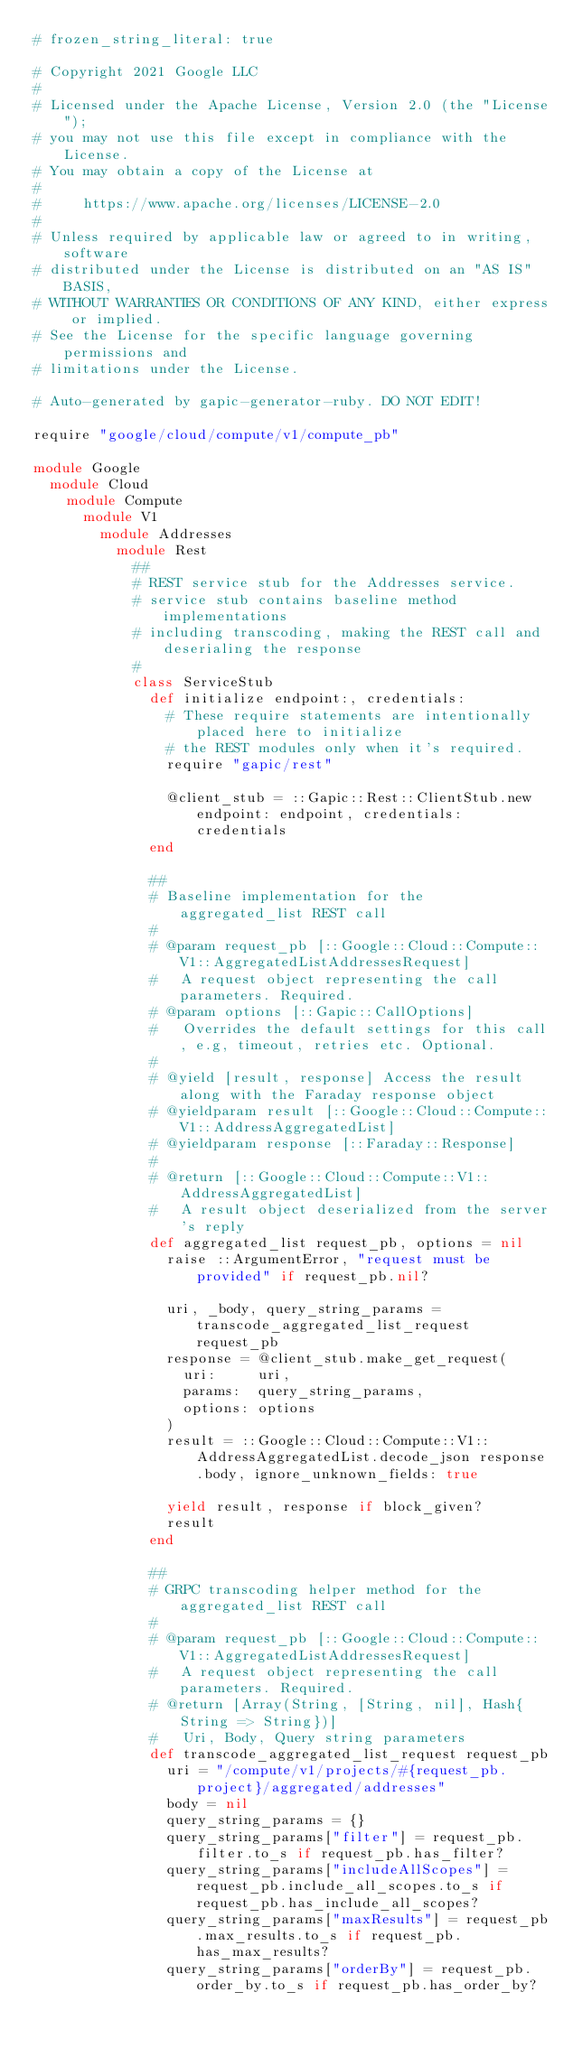Convert code to text. <code><loc_0><loc_0><loc_500><loc_500><_Ruby_># frozen_string_literal: true

# Copyright 2021 Google LLC
#
# Licensed under the Apache License, Version 2.0 (the "License");
# you may not use this file except in compliance with the License.
# You may obtain a copy of the License at
#
#     https://www.apache.org/licenses/LICENSE-2.0
#
# Unless required by applicable law or agreed to in writing, software
# distributed under the License is distributed on an "AS IS" BASIS,
# WITHOUT WARRANTIES OR CONDITIONS OF ANY KIND, either express or implied.
# See the License for the specific language governing permissions and
# limitations under the License.

# Auto-generated by gapic-generator-ruby. DO NOT EDIT!

require "google/cloud/compute/v1/compute_pb"

module Google
  module Cloud
    module Compute
      module V1
        module Addresses
          module Rest
            ##
            # REST service stub for the Addresses service.
            # service stub contains baseline method implementations
            # including transcoding, making the REST call and deserialing the response
            #
            class ServiceStub
              def initialize endpoint:, credentials:
                # These require statements are intentionally placed here to initialize
                # the REST modules only when it's required.
                require "gapic/rest"

                @client_stub = ::Gapic::Rest::ClientStub.new endpoint: endpoint, credentials: credentials
              end

              ##
              # Baseline implementation for the aggregated_list REST call
              #
              # @param request_pb [::Google::Cloud::Compute::V1::AggregatedListAddressesRequest]
              #   A request object representing the call parameters. Required.
              # @param options [::Gapic::CallOptions]
              #   Overrides the default settings for this call, e.g, timeout, retries etc. Optional.
              #
              # @yield [result, response] Access the result along with the Faraday response object
              # @yieldparam result [::Google::Cloud::Compute::V1::AddressAggregatedList]
              # @yieldparam response [::Faraday::Response]
              #
              # @return [::Google::Cloud::Compute::V1::AddressAggregatedList]
              #   A result object deserialized from the server's reply
              def aggregated_list request_pb, options = nil
                raise ::ArgumentError, "request must be provided" if request_pb.nil?

                uri, _body, query_string_params = transcode_aggregated_list_request request_pb
                response = @client_stub.make_get_request(
                  uri:     uri,
                  params:  query_string_params,
                  options: options
                )
                result = ::Google::Cloud::Compute::V1::AddressAggregatedList.decode_json response.body, ignore_unknown_fields: true

                yield result, response if block_given?
                result
              end

              ##
              # GRPC transcoding helper method for the aggregated_list REST call
              #
              # @param request_pb [::Google::Cloud::Compute::V1::AggregatedListAddressesRequest]
              #   A request object representing the call parameters. Required.
              # @return [Array(String, [String, nil], Hash{String => String})]
              #   Uri, Body, Query string parameters
              def transcode_aggregated_list_request request_pb
                uri = "/compute/v1/projects/#{request_pb.project}/aggregated/addresses"
                body = nil
                query_string_params = {}
                query_string_params["filter"] = request_pb.filter.to_s if request_pb.has_filter?
                query_string_params["includeAllScopes"] = request_pb.include_all_scopes.to_s if request_pb.has_include_all_scopes?
                query_string_params["maxResults"] = request_pb.max_results.to_s if request_pb.has_max_results?
                query_string_params["orderBy"] = request_pb.order_by.to_s if request_pb.has_order_by?</code> 